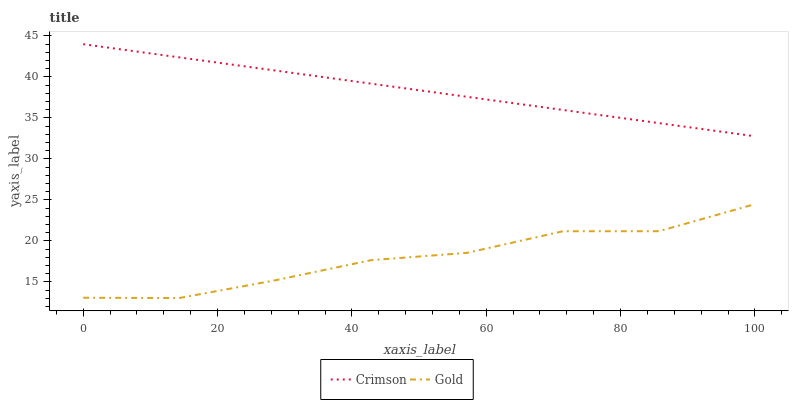Does Gold have the minimum area under the curve?
Answer yes or no. Yes. Does Crimson have the maximum area under the curve?
Answer yes or no. Yes. Does Gold have the maximum area under the curve?
Answer yes or no. No. Is Crimson the smoothest?
Answer yes or no. Yes. Is Gold the roughest?
Answer yes or no. Yes. Is Gold the smoothest?
Answer yes or no. No. Does Gold have the lowest value?
Answer yes or no. Yes. Does Crimson have the highest value?
Answer yes or no. Yes. Does Gold have the highest value?
Answer yes or no. No. Is Gold less than Crimson?
Answer yes or no. Yes. Is Crimson greater than Gold?
Answer yes or no. Yes. Does Gold intersect Crimson?
Answer yes or no. No. 